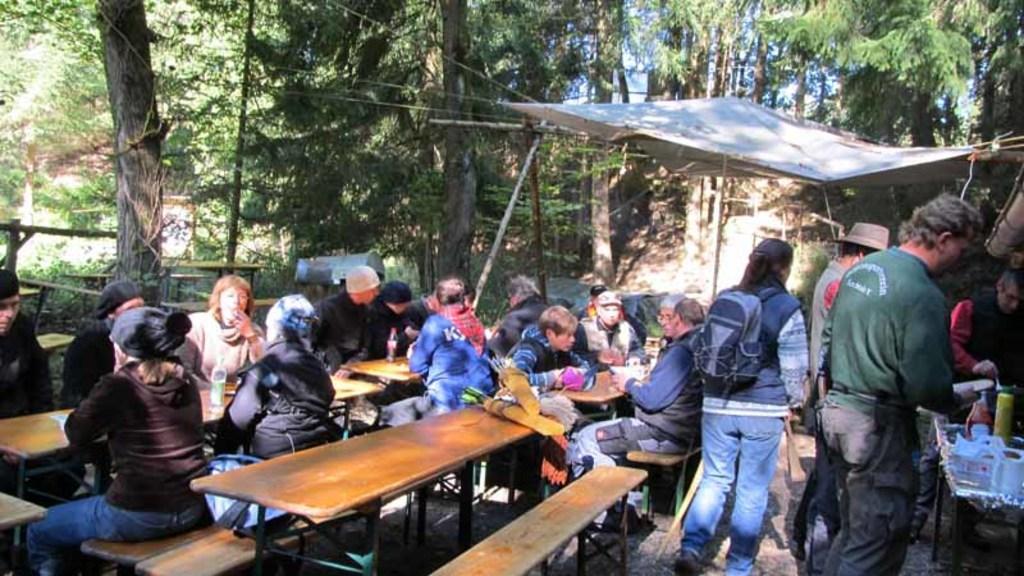In one or two sentences, can you explain what this image depicts? In this image, There are some tables in yellow color and there are some people sitting on the table, In the right side there is a man standing and there is a table on that there are some plates, In the background there are some trees in green color and there is a shed in white color 